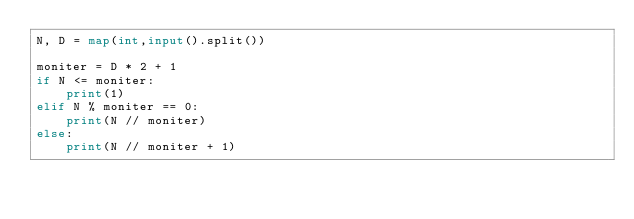<code> <loc_0><loc_0><loc_500><loc_500><_Python_>N, D = map(int,input().split())

moniter = D * 2 + 1
if N <= moniter:
    print(1)
elif N % moniter == 0:
    print(N // moniter)
else:
    print(N // moniter + 1)</code> 